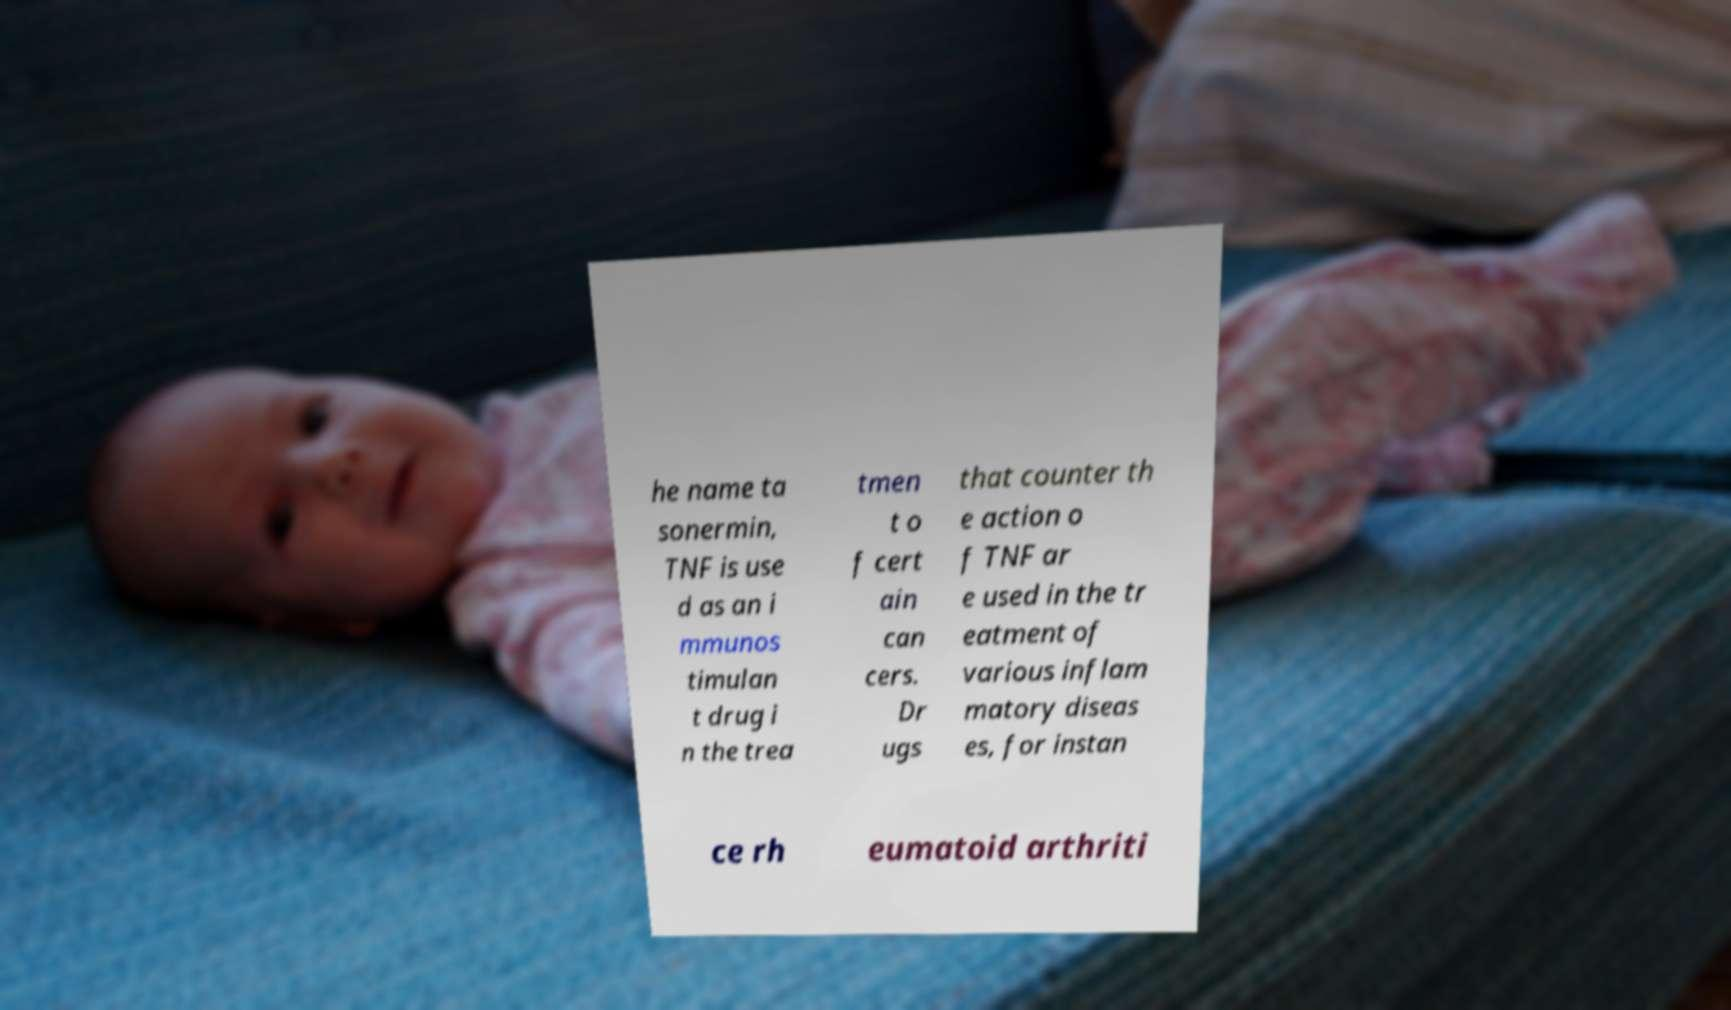For documentation purposes, I need the text within this image transcribed. Could you provide that? he name ta sonermin, TNF is use d as an i mmunos timulan t drug i n the trea tmen t o f cert ain can cers. Dr ugs that counter th e action o f TNF ar e used in the tr eatment of various inflam matory diseas es, for instan ce rh eumatoid arthriti 